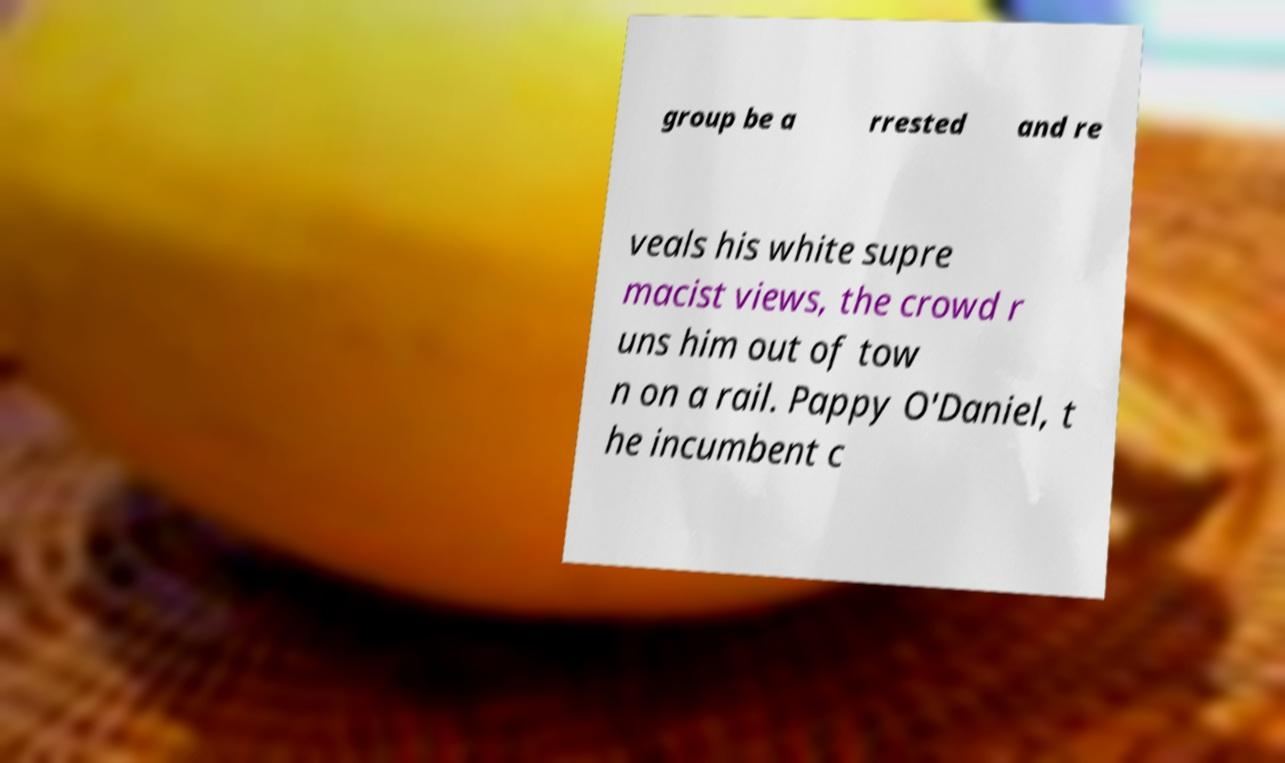For documentation purposes, I need the text within this image transcribed. Could you provide that? group be a rrested and re veals his white supre macist views, the crowd r uns him out of tow n on a rail. Pappy O'Daniel, t he incumbent c 